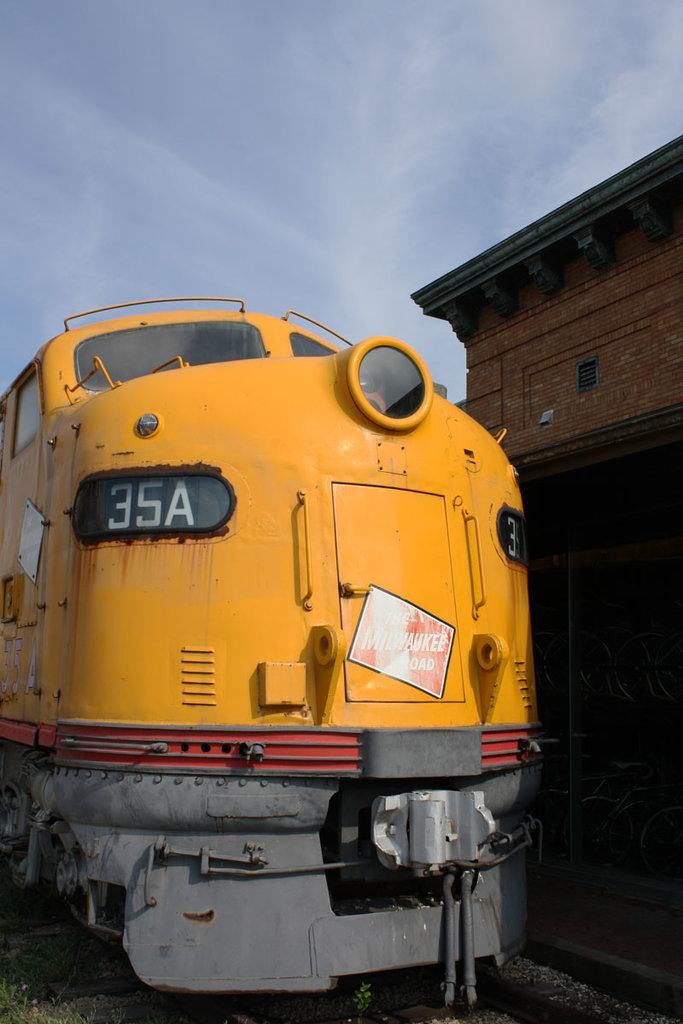What is the trains number?
Offer a terse response. 35a. 